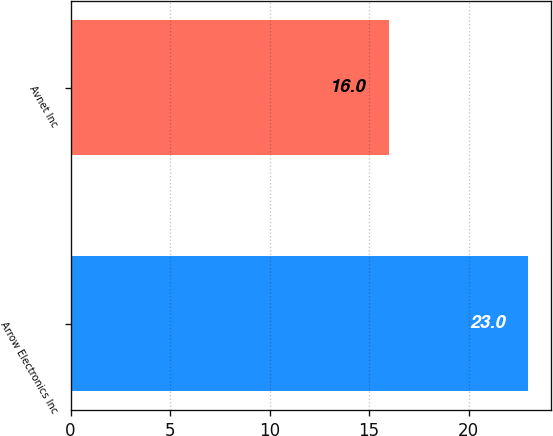<chart> <loc_0><loc_0><loc_500><loc_500><bar_chart><fcel>Arrow Electronics Inc<fcel>Avnet Inc<nl><fcel>23<fcel>16<nl></chart> 